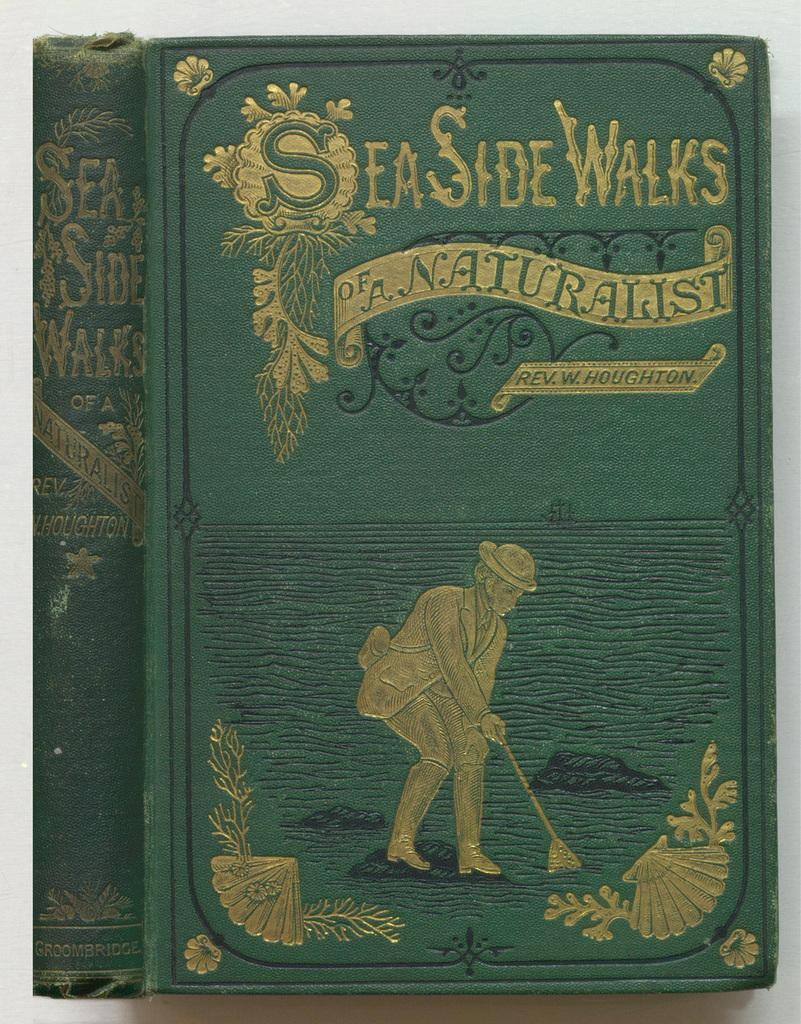Provide a one-sentence caption for the provided image. An old copy of SeaSide Walks has a gold embossed cover. 